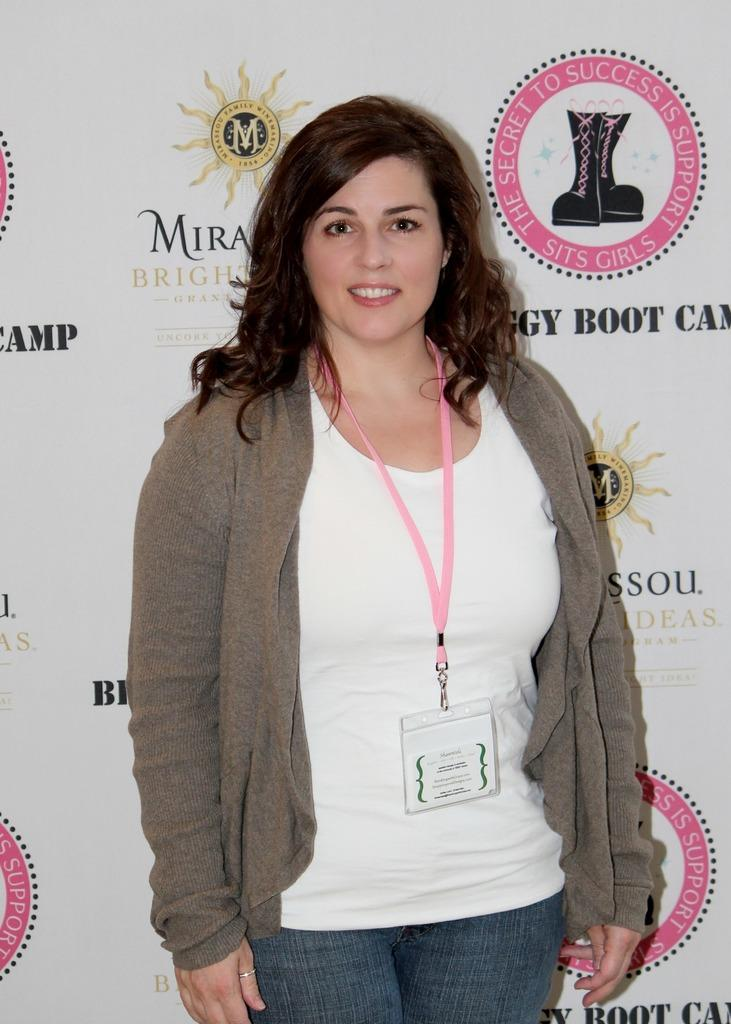Who is the main subject in the image? There is a woman standing in the center of the image. What is the woman wearing? The woman is wearing a jacket. What can be seen behind the woman? There is a banner behind the woman. What type of ball is being used in the event depicted in the image? There is no event or ball present in the image; it features a woman standing in the center with a banner behind her. 